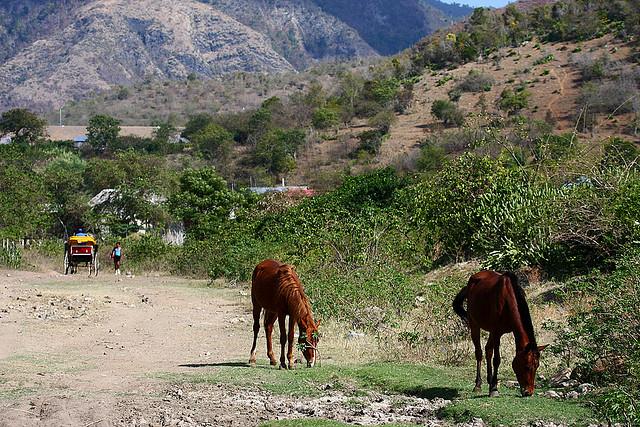What animal is on the right?
Give a very brief answer. Horse. Is this a good vacation spot?
Answer briefly. Yes. What breed is the horse on the right?
Keep it brief. Arabian. Is it sunny?
Concise answer only. Yes. 